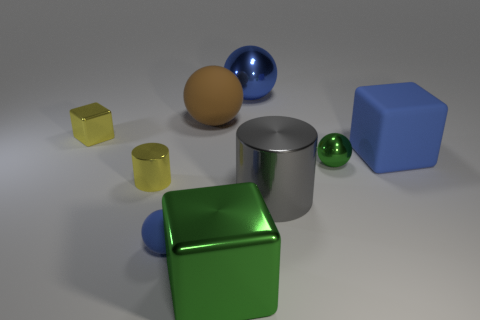What is the material of the yellow thing that is in front of the sphere that is on the right side of the blue sphere that is behind the blue rubber ball?
Provide a short and direct response. Metal. What material is the tiny cylinder?
Provide a succinct answer. Metal. There is a blue metal thing that is the same shape as the tiny matte object; what is its size?
Make the answer very short. Large. Does the large shiny sphere have the same color as the small cylinder?
Offer a very short reply. No. How many other objects are there of the same material as the large blue sphere?
Ensure brevity in your answer.  5. Are there an equal number of big brown spheres that are right of the blue rubber ball and brown objects?
Provide a short and direct response. Yes. Is the size of the green object that is left of the blue metal sphere the same as the tiny green metallic sphere?
Give a very brief answer. No. What number of tiny green metal spheres are behind the large blue matte object?
Provide a short and direct response. 0. There is a large thing that is in front of the tiny green object and behind the green metal block; what is it made of?
Your response must be concise. Metal. What number of big things are either gray cylinders or blue matte cubes?
Keep it short and to the point. 2. 